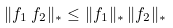Convert formula to latex. <formula><loc_0><loc_0><loc_500><loc_500>\| f _ { 1 } \, f _ { 2 } \| _ { * } \leq \| f _ { 1 } \| _ { * } \, \| f _ { 2 } \| _ { * }</formula> 